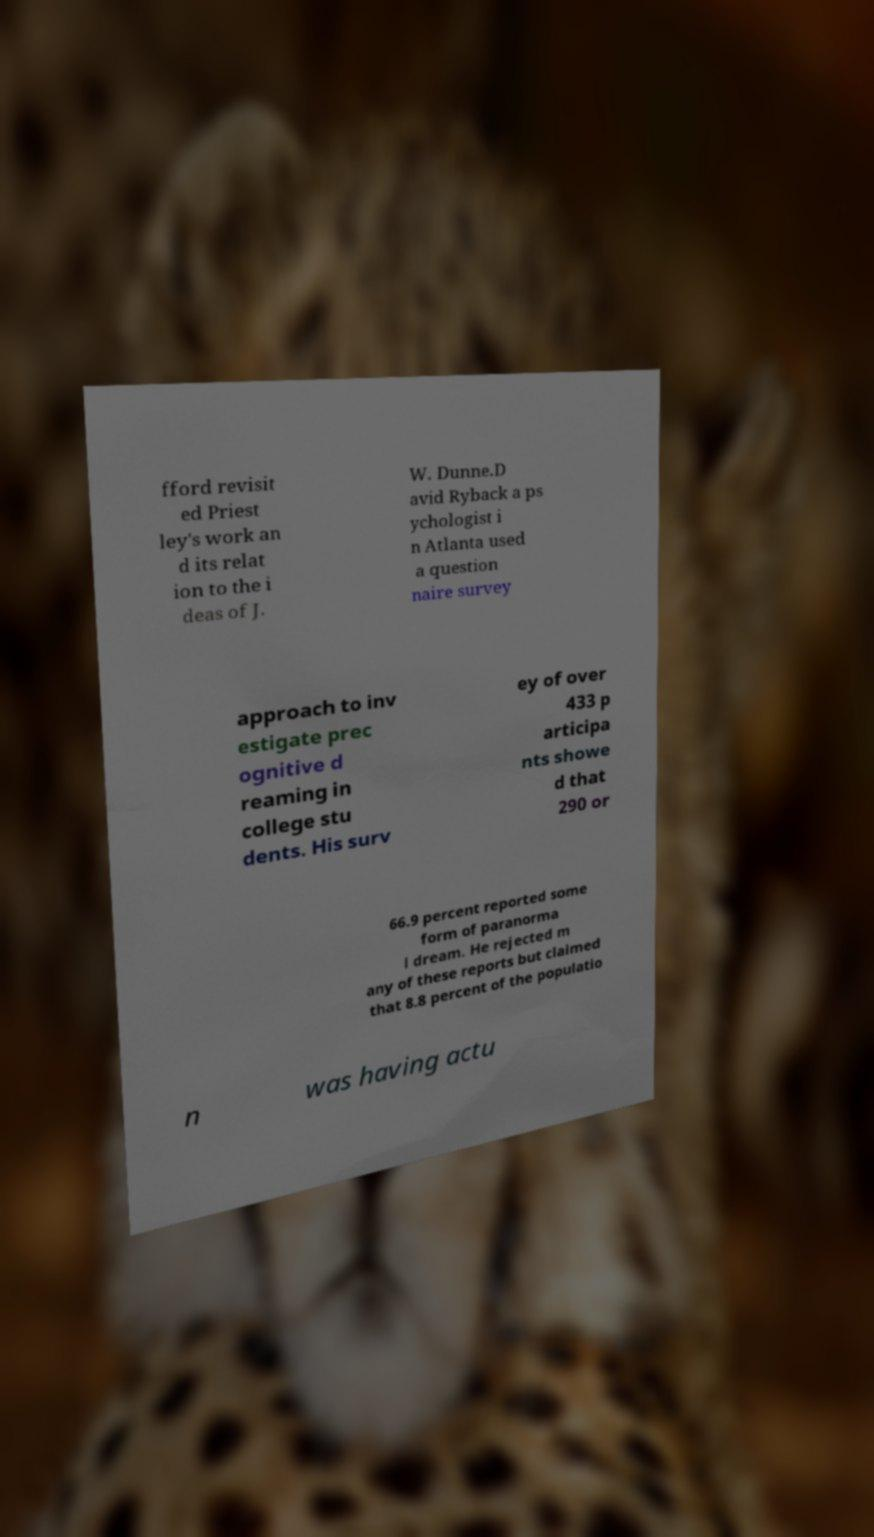Can you accurately transcribe the text from the provided image for me? fford revisit ed Priest ley's work an d its relat ion to the i deas of J. W. Dunne.D avid Ryback a ps ychologist i n Atlanta used a question naire survey approach to inv estigate prec ognitive d reaming in college stu dents. His surv ey of over 433 p articipa nts showe d that 290 or 66.9 percent reported some form of paranorma l dream. He rejected m any of these reports but claimed that 8.8 percent of the populatio n was having actu 